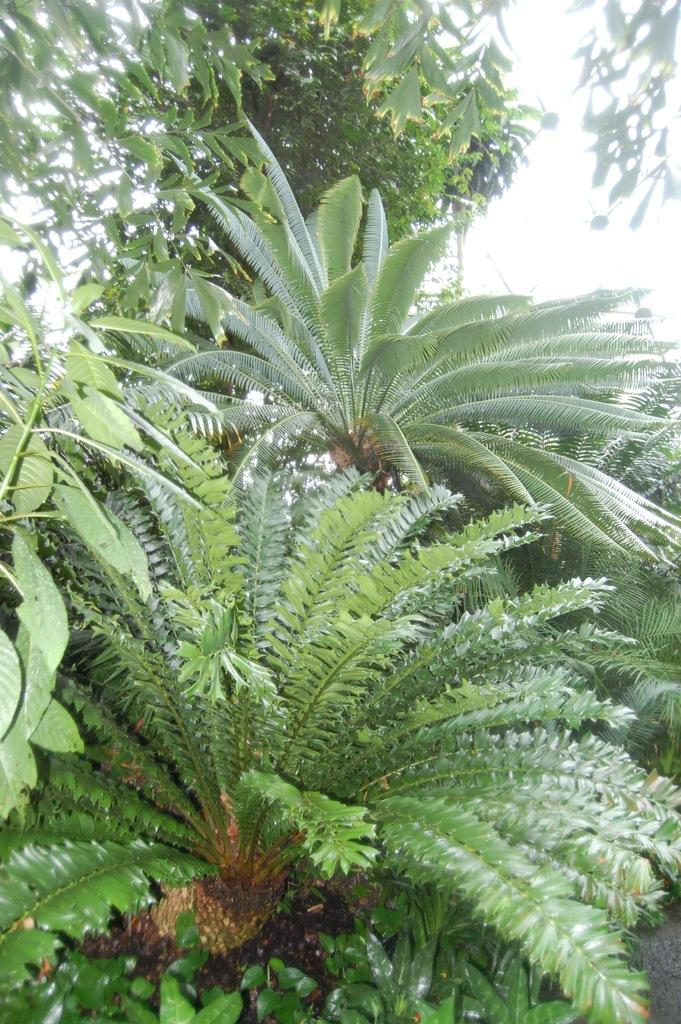What type of vegetation can be seen in the image? There are plants and trees in the image. What part of the natural environment is visible in the image? The sky is visible in the background of the image. How many types of vegetation are present in the image? There are two types of vegetation: plants and trees. What color is the coat worn by the son in the image? There is no son or coat present in the image. 